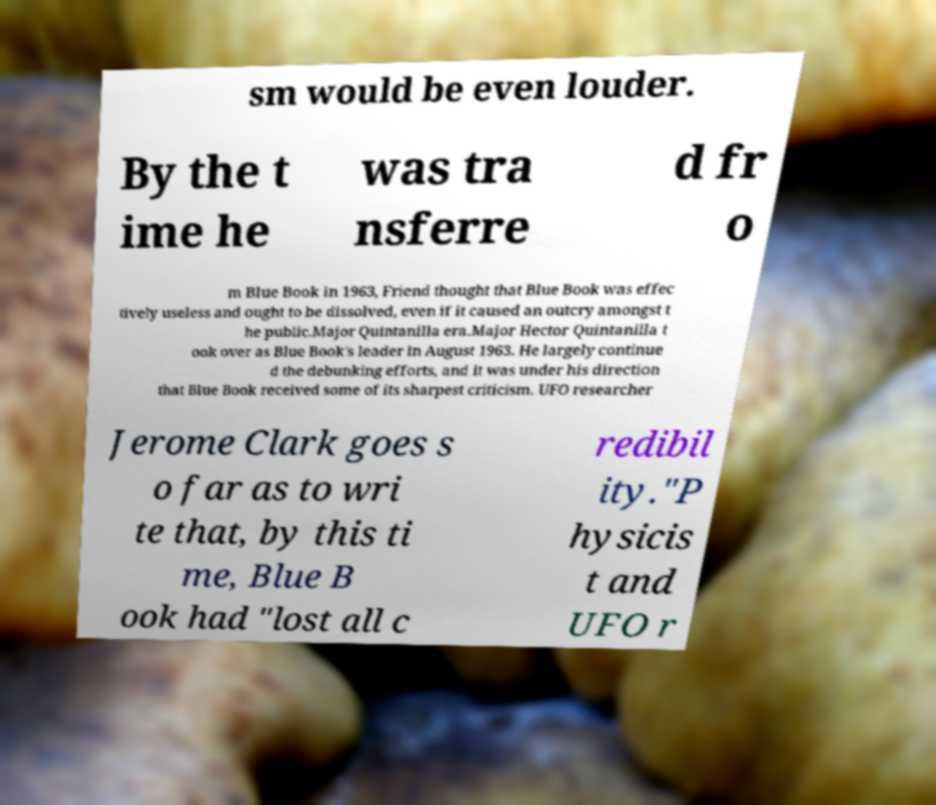I need the written content from this picture converted into text. Can you do that? sm would be even louder. By the t ime he was tra nsferre d fr o m Blue Book in 1963, Friend thought that Blue Book was effec tively useless and ought to be dissolved, even if it caused an outcry amongst t he public.Major Quintanilla era.Major Hector Quintanilla t ook over as Blue Book's leader in August 1963. He largely continue d the debunking efforts, and it was under his direction that Blue Book received some of its sharpest criticism. UFO researcher Jerome Clark goes s o far as to wri te that, by this ti me, Blue B ook had "lost all c redibil ity."P hysicis t and UFO r 